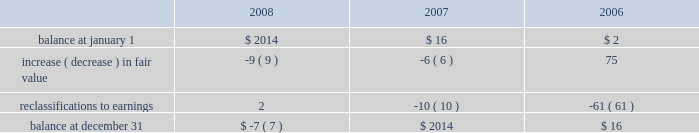Stockholders 2019 equity derivative instruments activity , net of tax , included in non-owner changes to equity within the consolidated statements of stockholders 2019 equity for the years ended december 31 , 2008 , 2007 and 2006 is as follows: .
Net investment in foreign operations hedge at december 31 , 2008 and 2007 , the company did not have any hedges of foreign currency exposure of net investments in foreign operations .
Investments hedge during the first quarter of 2006 , the company entered into a zero-cost collar derivative ( the 201csprint nextel derivative 201d ) to protect itself economically against price fluctuations in its 37.6 million shares of sprint nextel corporation ( 201csprint nextel 201d ) non-voting common stock .
During the second quarter of 2006 , as a result of sprint nextel 2019s spin-off of embarq corporation through a dividend to sprint nextel shareholders , the company received approximately 1.9 million shares of embarq corporation .
The floor and ceiling prices of the sprint nextel derivative were adjusted accordingly .
The sprint nextel derivative was not designated as a hedge under the provisions of sfas no .
133 , 201caccounting for derivative instruments and hedging activities . 201d accordingly , to reflect the change in fair value of the sprint nextel derivative , the company recorded a net gain of $ 99 million for the year ended december 31 , 2006 , included in other income ( expense ) in the company 2019s consolidated statements of operations .
In december 2006 , the sprint nextel derivative was terminated and settled in cash and the 37.6 million shares of sprint nextel were converted to common shares and sold .
The company received aggregate cash proceeds of approximately $ 820 million from the settlement of the sprint nextel derivative and the subsequent sale of the 37.6 million sprint nextel shares .
The company recognized a loss of $ 126 million in connection with the sale of the remaining shares of sprint nextel common stock .
As described above , the company recorded a net gain of $ 99 million in connection with the sprint nextel derivative .
Fair value of financial instruments the company 2019s financial instruments include cash equivalents , sigma fund investments , short-term investments , accounts receivable , long-term receivables , accounts payable , accrued liabilities , derivatives and other financing commitments .
The company 2019s sigma fund , available-for-sale investment portfolios and derivatives are recorded in the company 2019s consolidated balance sheets at fair value .
All other financial instruments , with the exception of long-term debt , are carried at cost , which is not materially different than the instruments 2019 fair values .
Using quoted market prices and market interest rates , the company determined that the fair value of long- term debt at december 31 , 2008 was $ 2.8 billion , compared to a carrying value of $ 4.1 billion .
Since considerable judgment is required in interpreting market information , the fair value of the long-term debt is not necessarily indicative of the amount which could be realized in a current market exchange .
Equity price market risk at december 31 , 2008 , the company 2019s available-for-sale equity securities portfolio had an approximate fair market value of $ 128 million , which represented a cost basis of $ 125 million and a net unrealized loss of $ 3 million .
These equity securities are held for purposes other than trading .
%%transmsg*** transmitting job : c49054 pcn : 105000000 ***%%pcmsg|102 |00022|yes|no|02/23/2009 19:17|0|0|page is valid , no graphics -- color : n| .
What was the change in the reclassification to earnings from 2007 to 2008? 
Computations: (2 - -10)
Answer: 12.0. 